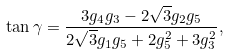Convert formula to latex. <formula><loc_0><loc_0><loc_500><loc_500>\tan { \gamma } = \frac { 3 g _ { 4 } g _ { 3 } - 2 \sqrt { 3 } g _ { 2 } g _ { 5 } } { 2 \sqrt { 3 } g _ { 1 } g _ { 5 } + 2 g _ { 5 } ^ { 2 } + 3 g _ { 3 } ^ { 2 } } ,</formula> 